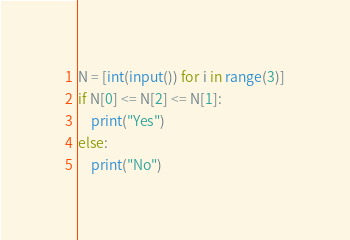Convert code to text. <code><loc_0><loc_0><loc_500><loc_500><_Python_>N = [int(input()) for i in range(3)]
if N[0] <= N[2] <= N[1]:
    print("Yes")
else:
    print("No")</code> 